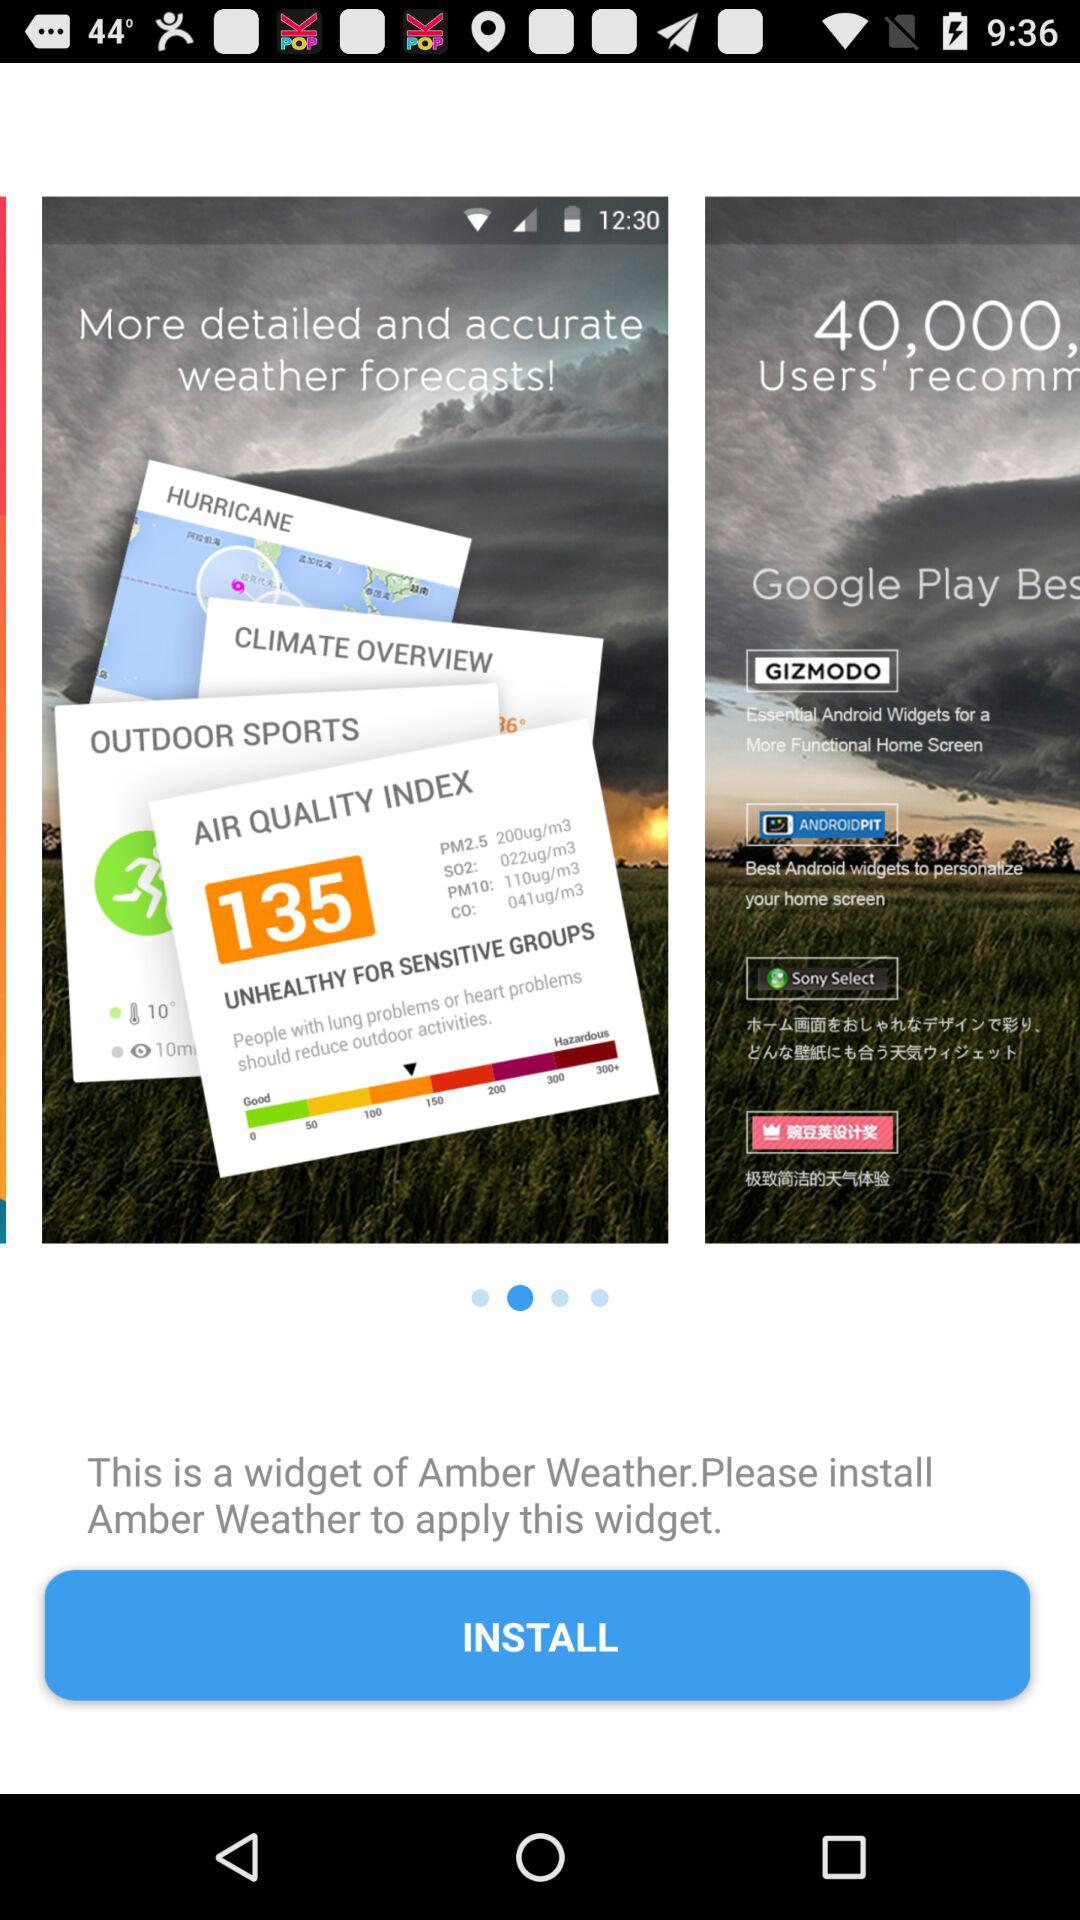What do we need to do to apply the widget? You need to install "Amber Weather" to apply the widget. 